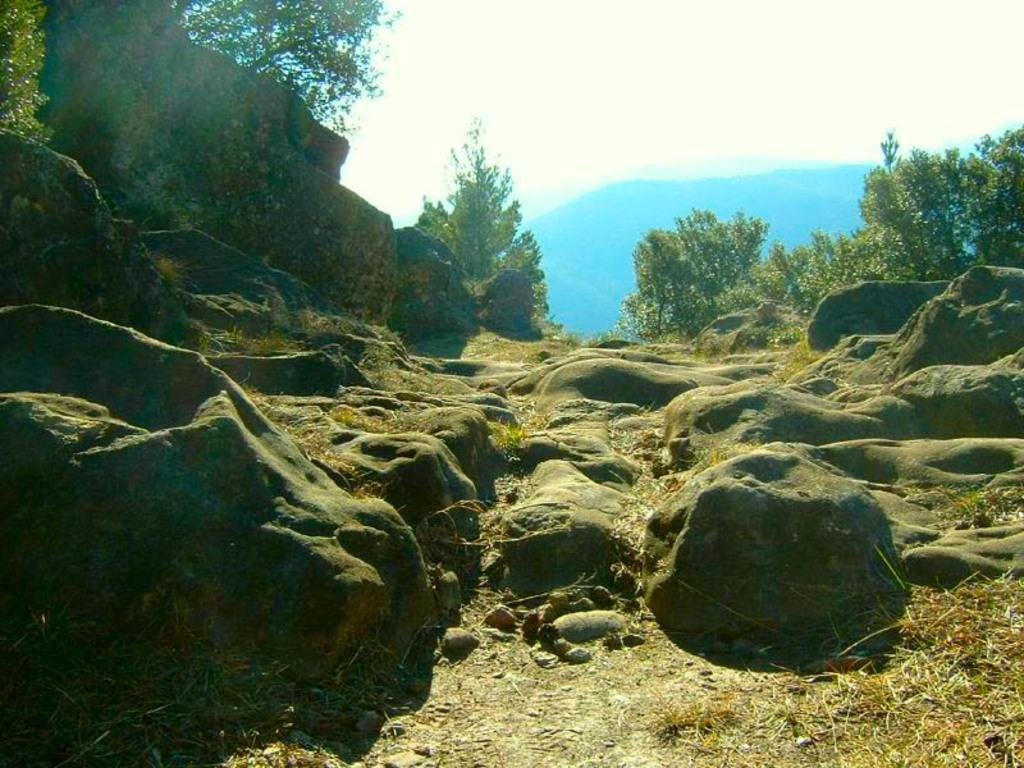What type of natural elements can be seen on the ground in the image? There are stones and rocks on the ground in the image. What type of vegetation is present in the image? There are trees in the image. What can be seen in the distance in the background of the image? There is a mountain in the background. What is visible above the mountain in the image? The sky is visible in the background. How many wounds can be seen on the trees in the image? There are no wounds visible on the trees in the image. What type of vegetable is growing near the mountain in the image? There is no vegetable, specifically cabbage, present in the image. 